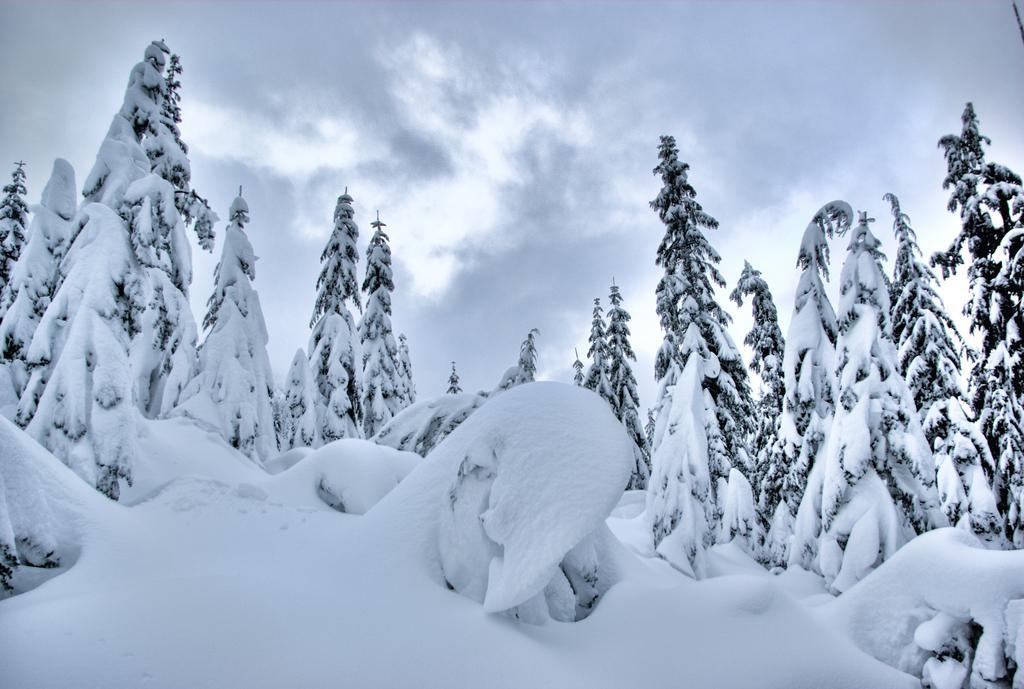How would you summarize this image in a sentence or two? In this image we can see the snow, there are few trees with snow, in the background we can see the sky with clouds. 